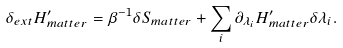Convert formula to latex. <formula><loc_0><loc_0><loc_500><loc_500>\delta _ { e x t } H ^ { \prime } _ { m a t t e r } = \beta ^ { - 1 } \delta S _ { m a t t e r } + \sum _ { i } \partial _ { \lambda _ { i } } H ^ { \prime } _ { m a t t e r } \delta \lambda _ { i } .</formula> 